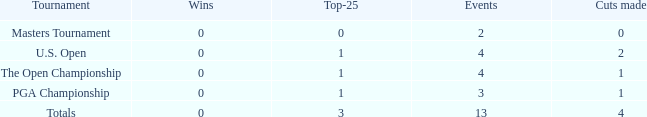How many cuts did he achieve at the pga championship in 3 events? None. 